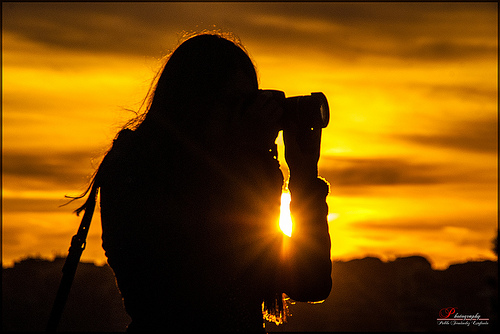<image>
Is there a sun behind the female? Yes. From this viewpoint, the sun is positioned behind the female, with the female partially or fully occluding the sun. 